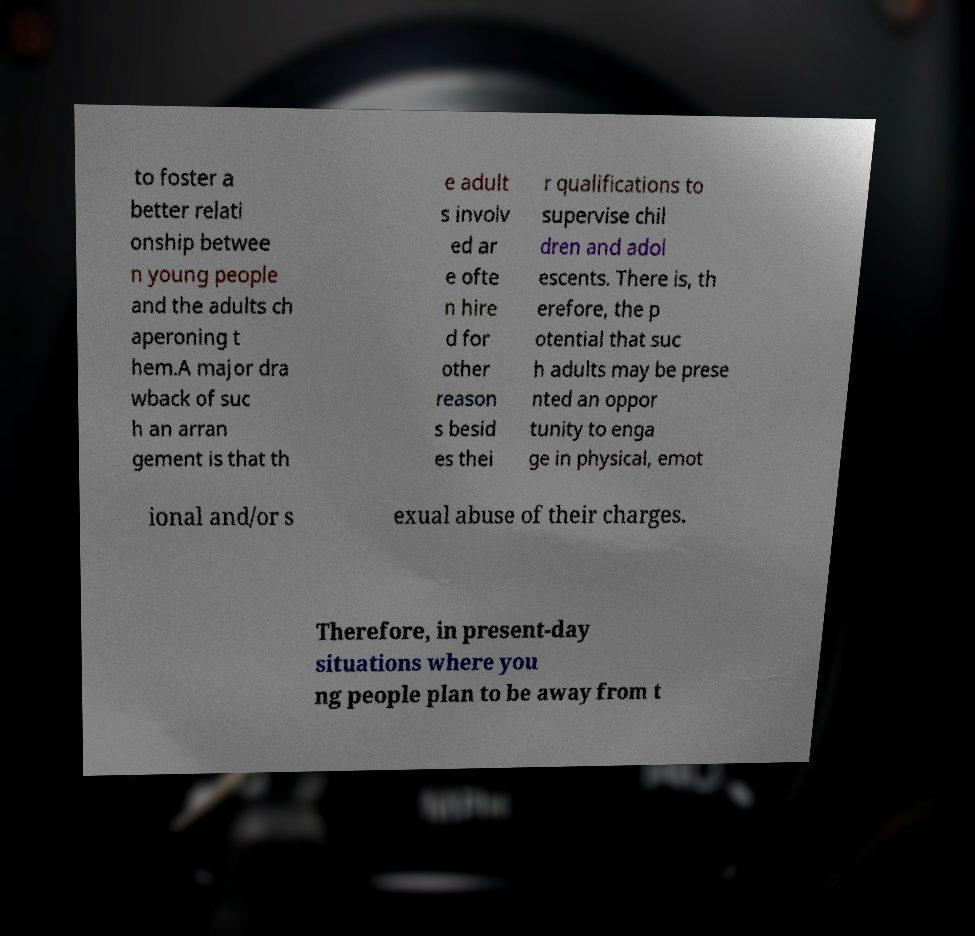For documentation purposes, I need the text within this image transcribed. Could you provide that? to foster a better relati onship betwee n young people and the adults ch aperoning t hem.A major dra wback of suc h an arran gement is that th e adult s involv ed ar e ofte n hire d for other reason s besid es thei r qualifications to supervise chil dren and adol escents. There is, th erefore, the p otential that suc h adults may be prese nted an oppor tunity to enga ge in physical, emot ional and/or s exual abuse of their charges. Therefore, in present-day situations where you ng people plan to be away from t 